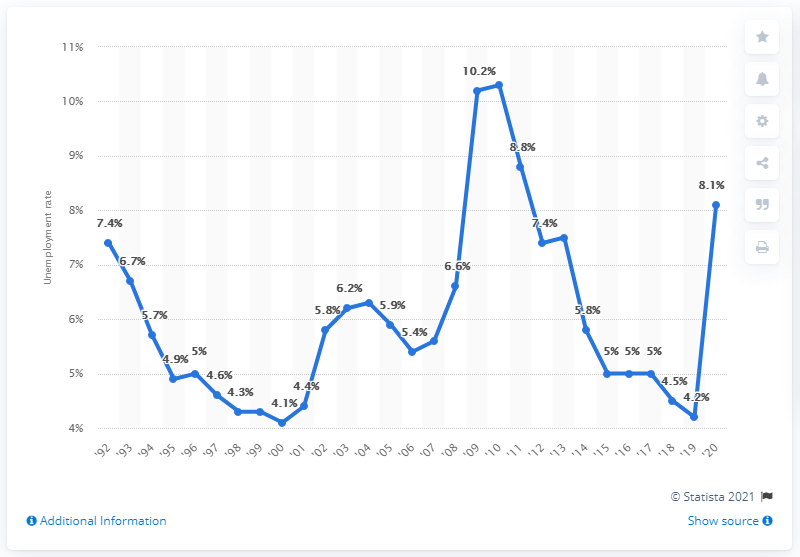Identify some key points in this picture. In 2010, the unemployment rate in Ohio was 4.2%. In 2010, Ohio's highest unemployment rate was 10.3%. In 2020, the state of Ohio experienced an unemployment rate of 8.1%. 